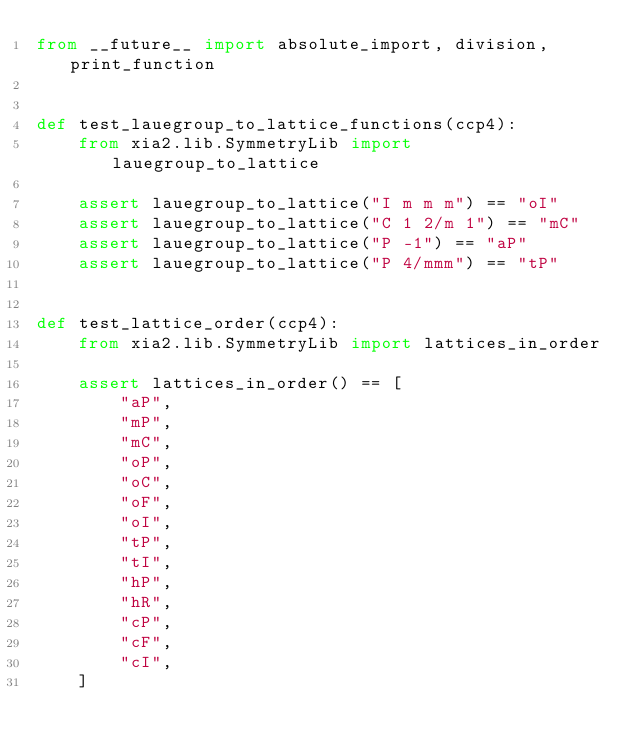Convert code to text. <code><loc_0><loc_0><loc_500><loc_500><_Python_>from __future__ import absolute_import, division, print_function


def test_lauegroup_to_lattice_functions(ccp4):
    from xia2.lib.SymmetryLib import lauegroup_to_lattice

    assert lauegroup_to_lattice("I m m m") == "oI"
    assert lauegroup_to_lattice("C 1 2/m 1") == "mC"
    assert lauegroup_to_lattice("P -1") == "aP"
    assert lauegroup_to_lattice("P 4/mmm") == "tP"


def test_lattice_order(ccp4):
    from xia2.lib.SymmetryLib import lattices_in_order

    assert lattices_in_order() == [
        "aP",
        "mP",
        "mC",
        "oP",
        "oC",
        "oF",
        "oI",
        "tP",
        "tI",
        "hP",
        "hR",
        "cP",
        "cF",
        "cI",
    ]
</code> 